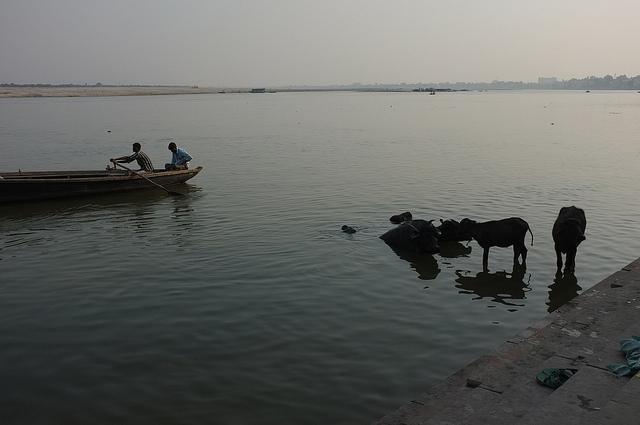How many people are on the boat?
Give a very brief answer. 2. 